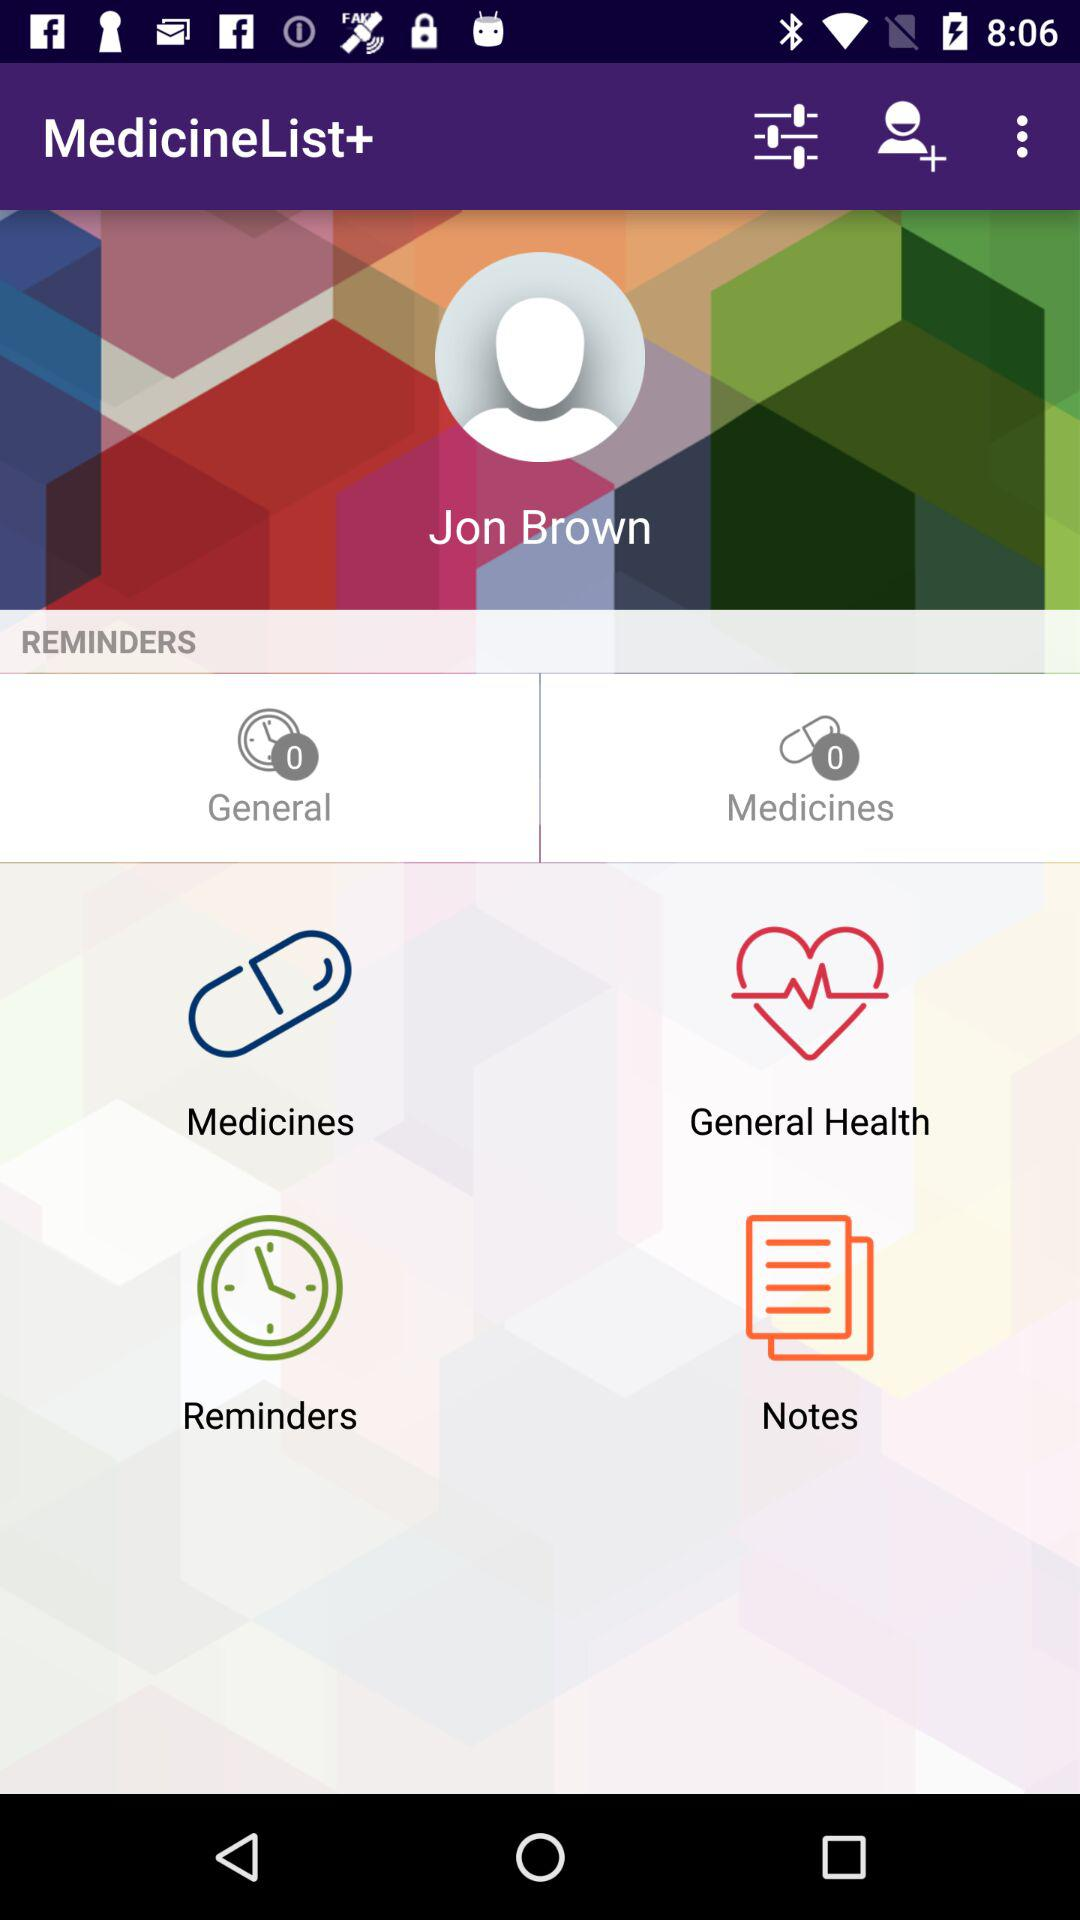What is the user name? The user name is Jon Brown. 